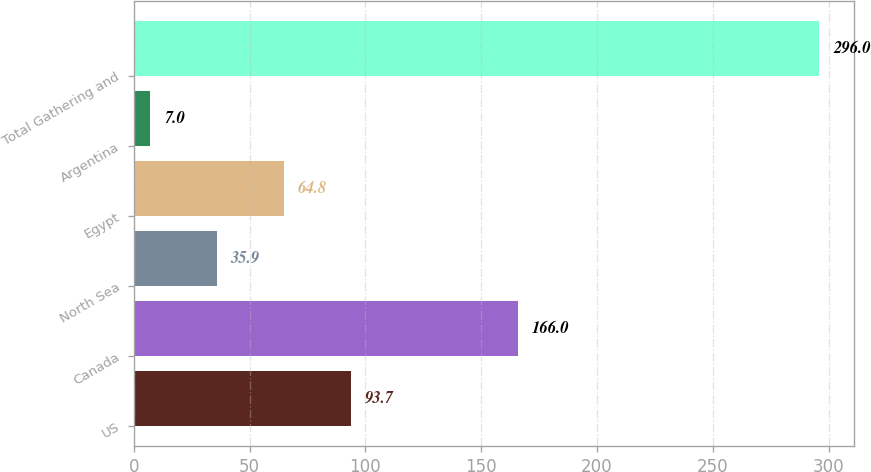<chart> <loc_0><loc_0><loc_500><loc_500><bar_chart><fcel>US<fcel>Canada<fcel>North Sea<fcel>Egypt<fcel>Argentina<fcel>Total Gathering and<nl><fcel>93.7<fcel>166<fcel>35.9<fcel>64.8<fcel>7<fcel>296<nl></chart> 